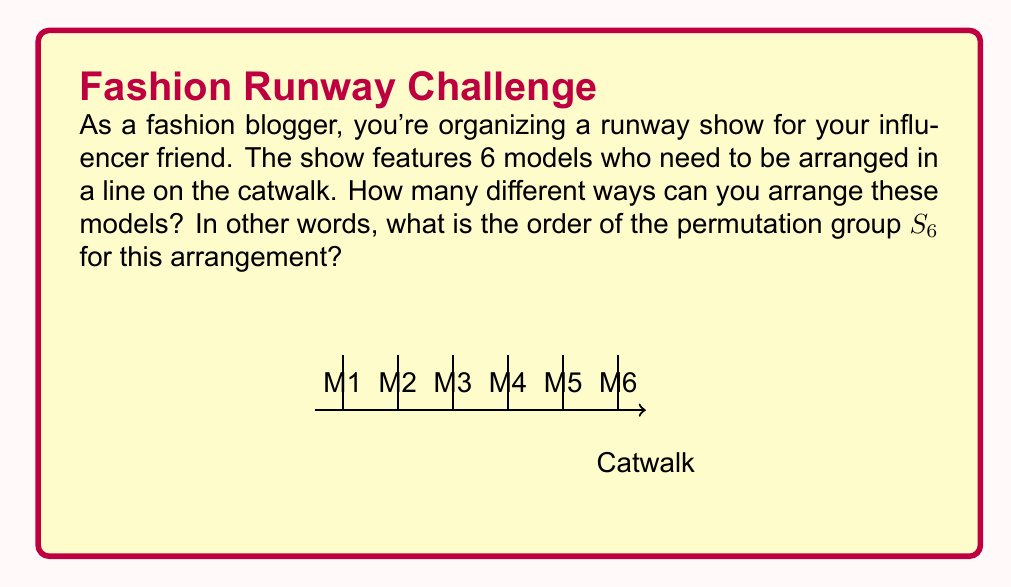Teach me how to tackle this problem. Let's approach this step-by-step:

1) In group theory, the arrangement of n distinct objects is represented by the symmetric group $S_n$. In this case, we have 6 models, so we're dealing with $S_6$.

2) The order of a permutation group $S_n$ is equal to $n!$ (n factorial). This is because:
   - For the first position, we have n choices
   - For the second position, we have (n-1) choices
   - For the third position, we have (n-2) choices
   - And so on, until we have only 1 choice for the last position

3) Therefore, the total number of permutations is:
   $n \times (n-1) \times (n-2) \times ... \times 2 \times 1 = n!$

4) In our case, $n = 6$, so we need to calculate $6!$:

   $6! = 6 \times 5 \times 4 \times 3 \times 2 \times 1 = 720$

5) This means there are 720 different ways to arrange 6 models on the runway.

6) In group theory terms, we say that the order of the permutation group $S_6$ is 720.
Answer: $|S_6| = 720$ 